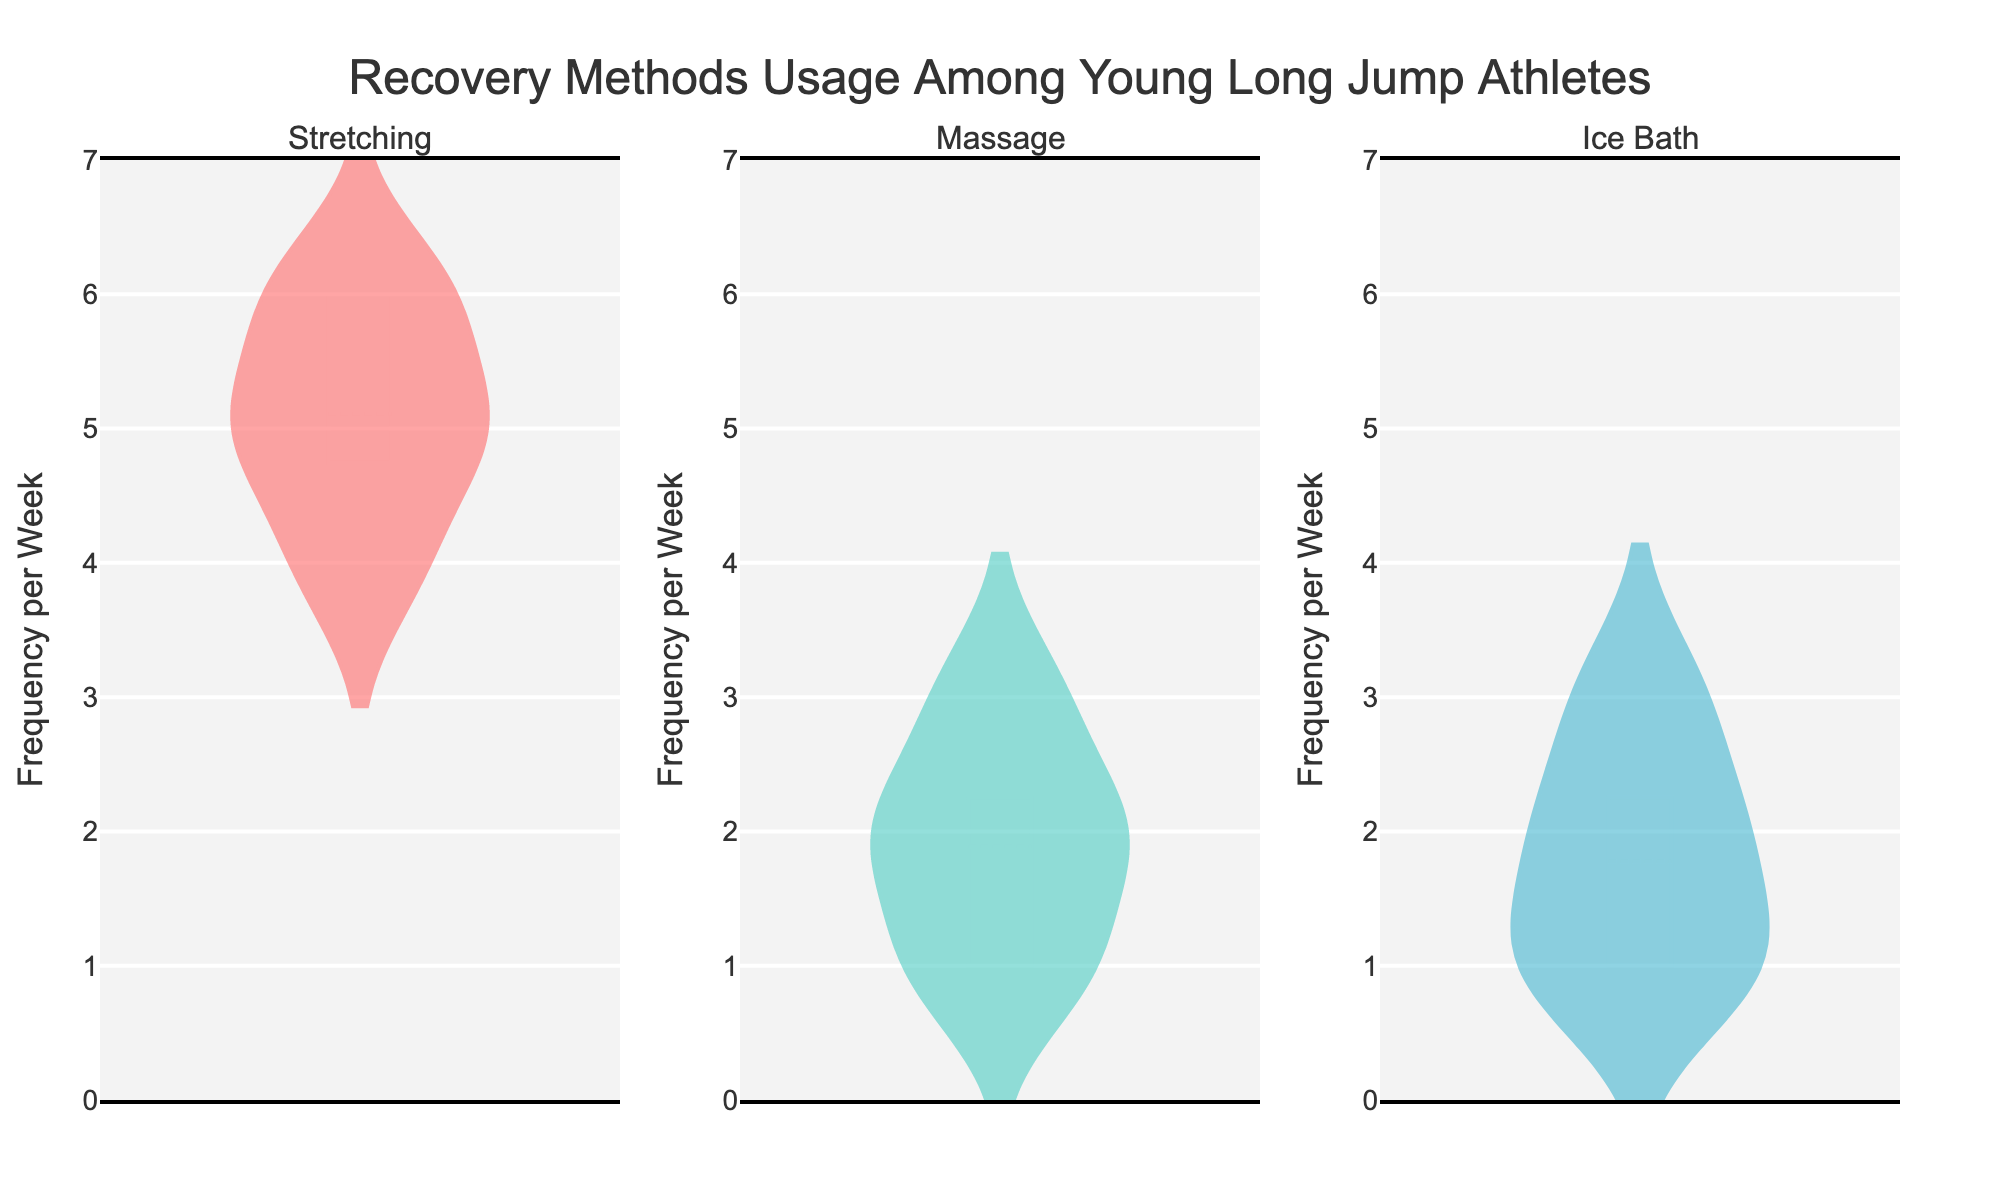How often is stretching used compared to massage among the athletes? By examining the violin plots for stretching and massage, we see the distribution and the median frequency. Stretching has higher usage than massage overall as indicated by the heights and median lines of the plots.
Answer: Stretching is used more often than massage What is the median frequency per week for ice baths? By identifying the horizontal line in the middle of the ice bath violin plot, we find the median. The median line appears at 2.
Answer: 2 Which recovery method shows the least variability in usage frequency? Variability is shown by the width of the violin plot. A narrower plot indicates less variability. By comparing the widths, ice baths have the narrowest plot.
Answer: Ice bath Are there any athletes that use stretching more than 6 times per week? The violin plot for stretching displays data points, and the top-most point is at 6, with no points above it.
Answer: No What is the range of frequencies used for massages? The range is from the minimum to maximum data points in the massage violin plot. We observe data from 1 to 3.
Answer: 1 to 3 Which recovery method is used most frequently on average? Comparing the mean line within each violin plot, stretching shows the highest average frequency, as indicated by its higher mean line.
Answer: Stretching How does the frequency of ice bath usage compare to stretching? By looking at the violin plots for ice baths and stretching, we see that the ice bath has a much lower median and narrower range compared to stretching.
Answer: Ice baths are used less frequently than stretching On average, how many more times per week is stretching used compared to massage? The mean lines for stretching and massage plots can be compared. Stretching has a mean of around 5, while massage has a mean around 2. So the difference is 5 - 2.
Answer: 3 Is there any overlap in the frequency of usage for massages and ice baths? By examining the range of both violin plots, we see that massage ranges from 1 to 3, while ice baths range from 1 to 3, showing an overlap.
Answer: Yes 